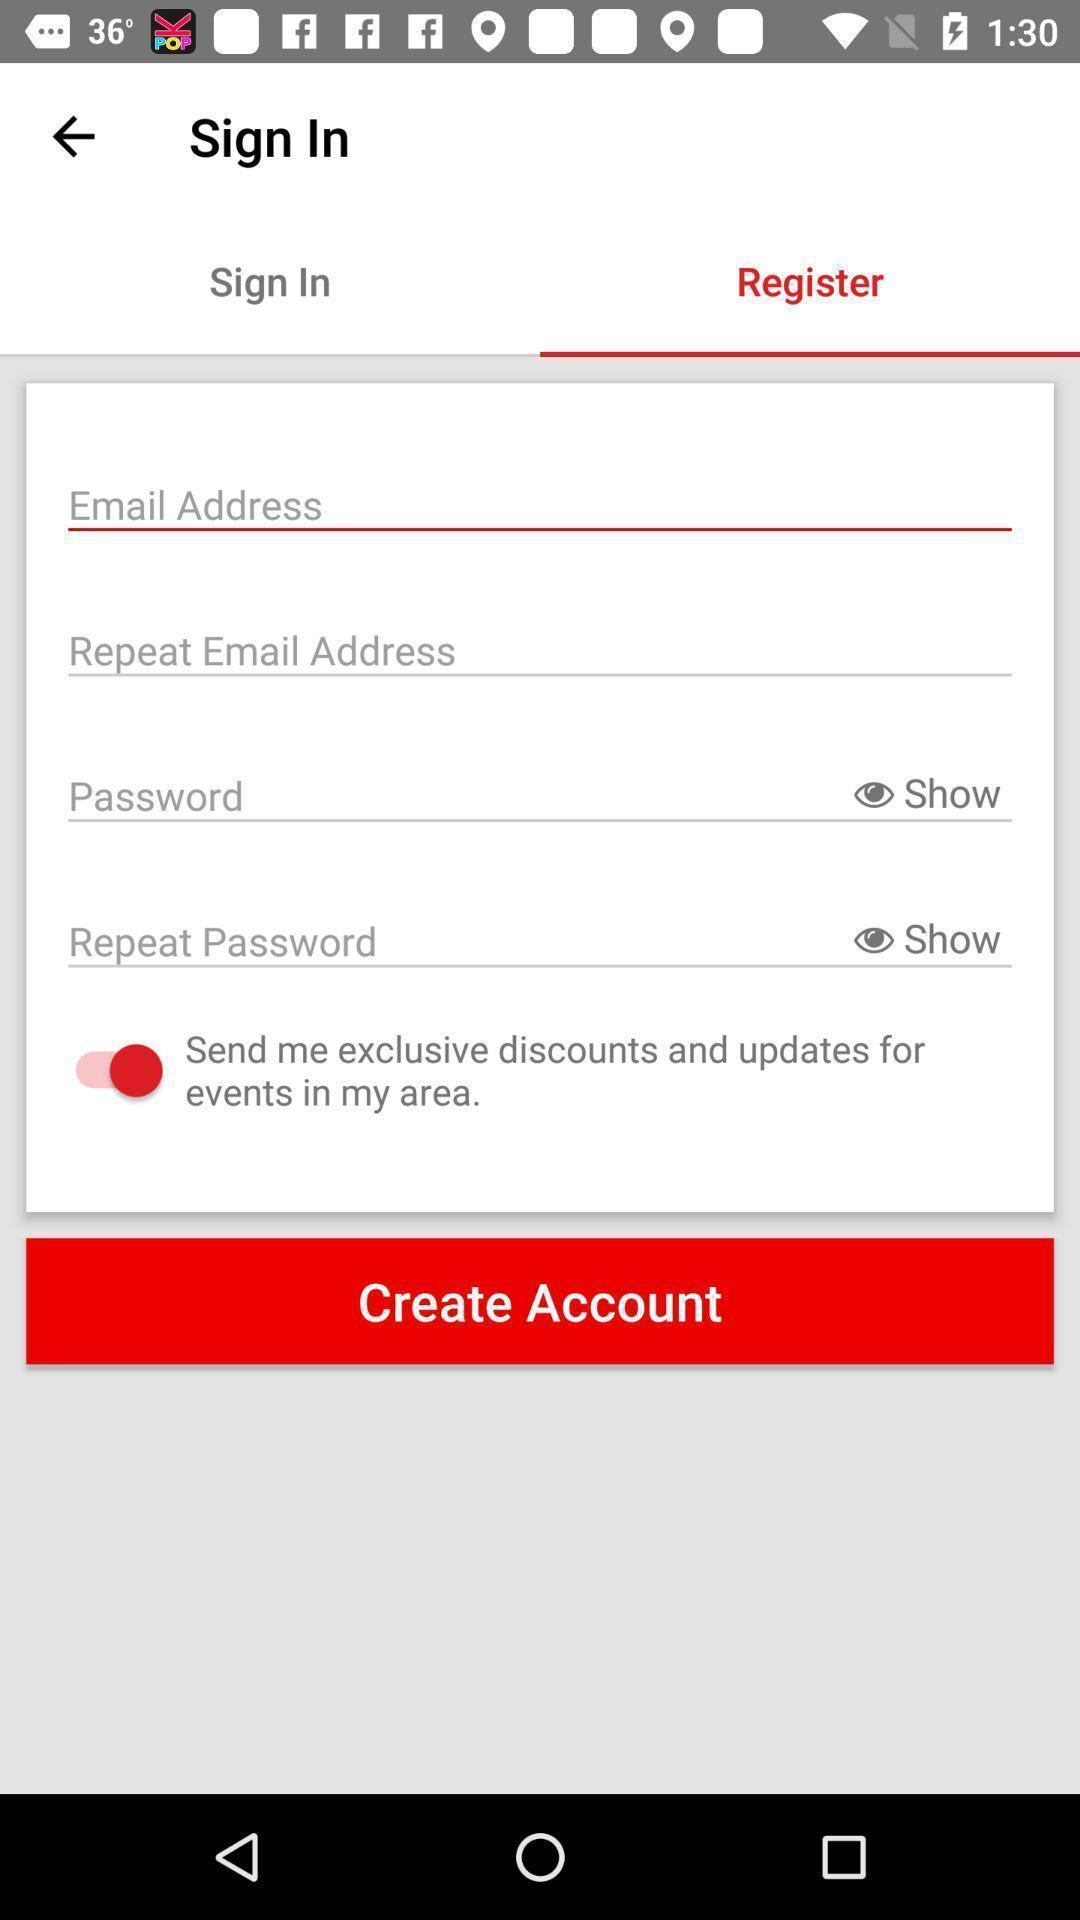Describe the key features of this screenshot. Sign in page to register. 